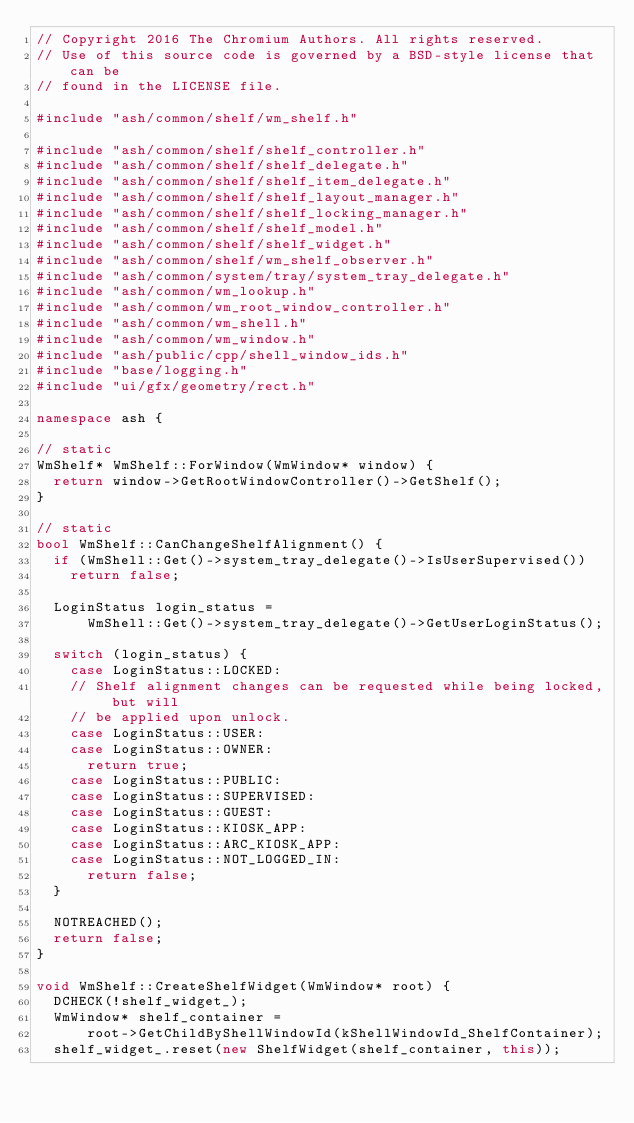Convert code to text. <code><loc_0><loc_0><loc_500><loc_500><_C++_>// Copyright 2016 The Chromium Authors. All rights reserved.
// Use of this source code is governed by a BSD-style license that can be
// found in the LICENSE file.

#include "ash/common/shelf/wm_shelf.h"

#include "ash/common/shelf/shelf_controller.h"
#include "ash/common/shelf/shelf_delegate.h"
#include "ash/common/shelf/shelf_item_delegate.h"
#include "ash/common/shelf/shelf_layout_manager.h"
#include "ash/common/shelf/shelf_locking_manager.h"
#include "ash/common/shelf/shelf_model.h"
#include "ash/common/shelf/shelf_widget.h"
#include "ash/common/shelf/wm_shelf_observer.h"
#include "ash/common/system/tray/system_tray_delegate.h"
#include "ash/common/wm_lookup.h"
#include "ash/common/wm_root_window_controller.h"
#include "ash/common/wm_shell.h"
#include "ash/common/wm_window.h"
#include "ash/public/cpp/shell_window_ids.h"
#include "base/logging.h"
#include "ui/gfx/geometry/rect.h"

namespace ash {

// static
WmShelf* WmShelf::ForWindow(WmWindow* window) {
  return window->GetRootWindowController()->GetShelf();
}

// static
bool WmShelf::CanChangeShelfAlignment() {
  if (WmShell::Get()->system_tray_delegate()->IsUserSupervised())
    return false;

  LoginStatus login_status =
      WmShell::Get()->system_tray_delegate()->GetUserLoginStatus();

  switch (login_status) {
    case LoginStatus::LOCKED:
    // Shelf alignment changes can be requested while being locked, but will
    // be applied upon unlock.
    case LoginStatus::USER:
    case LoginStatus::OWNER:
      return true;
    case LoginStatus::PUBLIC:
    case LoginStatus::SUPERVISED:
    case LoginStatus::GUEST:
    case LoginStatus::KIOSK_APP:
    case LoginStatus::ARC_KIOSK_APP:
    case LoginStatus::NOT_LOGGED_IN:
      return false;
  }

  NOTREACHED();
  return false;
}

void WmShelf::CreateShelfWidget(WmWindow* root) {
  DCHECK(!shelf_widget_);
  WmWindow* shelf_container =
      root->GetChildByShellWindowId(kShellWindowId_ShelfContainer);
  shelf_widget_.reset(new ShelfWidget(shelf_container, this));
</code> 